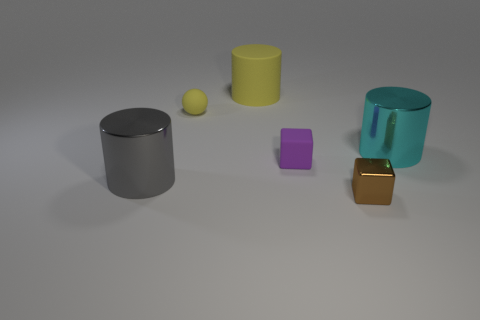Does the small purple cube have the same material as the tiny sphere?
Your answer should be compact. Yes. Are there an equal number of big yellow matte cylinders that are in front of the large cyan shiny thing and purple cubes that are behind the yellow rubber cylinder?
Offer a very short reply. Yes. How many small objects are on the right side of the purple thing?
Ensure brevity in your answer.  1. How many objects are either gray metallic things or rubber objects?
Your response must be concise. 4. How many other cylinders are the same size as the cyan cylinder?
Provide a short and direct response. 2. What is the shape of the small thing behind the big cylinder that is right of the tiny brown metallic cube?
Make the answer very short. Sphere. Is the number of purple cubes less than the number of yellow metallic cubes?
Provide a short and direct response. No. There is a big thing that is behind the cyan object; what color is it?
Offer a terse response. Yellow. There is a thing that is to the left of the big rubber cylinder and to the right of the large gray shiny thing; what is its material?
Keep it short and to the point. Rubber. What is the shape of the large gray thing that is made of the same material as the brown thing?
Provide a short and direct response. Cylinder. 